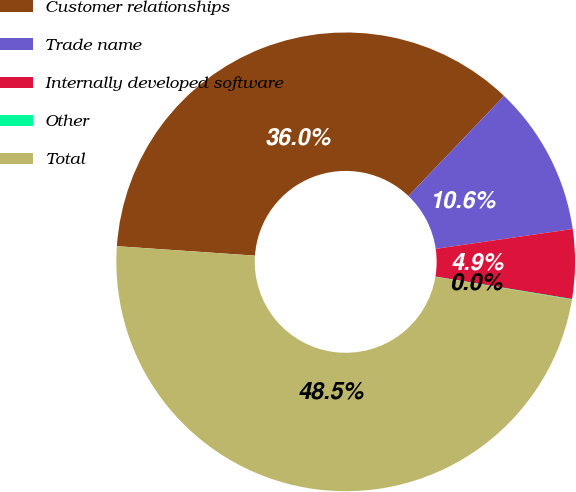Convert chart to OTSL. <chart><loc_0><loc_0><loc_500><loc_500><pie_chart><fcel>Customer relationships<fcel>Trade name<fcel>Internally developed software<fcel>Other<fcel>Total<nl><fcel>36.04%<fcel>10.58%<fcel>4.88%<fcel>0.04%<fcel>48.45%<nl></chart> 